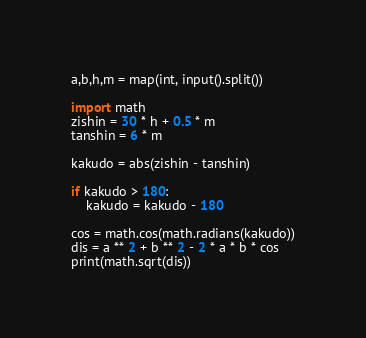<code> <loc_0><loc_0><loc_500><loc_500><_Python_>a,b,h,m = map(int, input().split())

import math
zishin = 30 * h + 0.5 * m 
tanshin = 6 * m

kakudo = abs(zishin - tanshin)

if kakudo > 180:
    kakudo = kakudo - 180
    
cos = math.cos(math.radians(kakudo))
dis = a ** 2 + b ** 2 - 2 * a * b * cos
print(math.sqrt(dis))</code> 